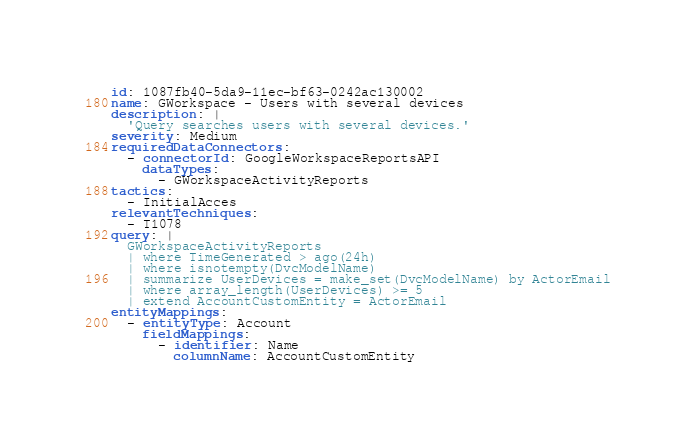<code> <loc_0><loc_0><loc_500><loc_500><_YAML_>id: 1087fb40-5da9-11ec-bf63-0242ac130002
name: GWorkspace - Users with several devices
description: |
  'Query searches users with several devices.'
severity: Medium
requiredDataConnectors:
  - connectorId: GoogleWorkspaceReportsAPI
    dataTypes:
      - GWorkspaceActivityReports
tactics:
  - InitialAcces
relevantTechniques:
  - T1078
query: |
  GWorkspaceActivityReports
  | where TimeGenerated > ago(24h)
  | where isnotempty(DvcModelName)
  | summarize UserDevices = make_set(DvcModelName) by ActorEmail
  | where array_length(UserDevices) >= 5
  | extend AccountCustomEntity = ActorEmail
entityMappings:
  - entityType: Account
    fieldMappings:
      - identifier: Name
        columnName: AccountCustomEntity
</code> 